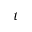Convert formula to latex. <formula><loc_0><loc_0><loc_500><loc_500>t</formula> 